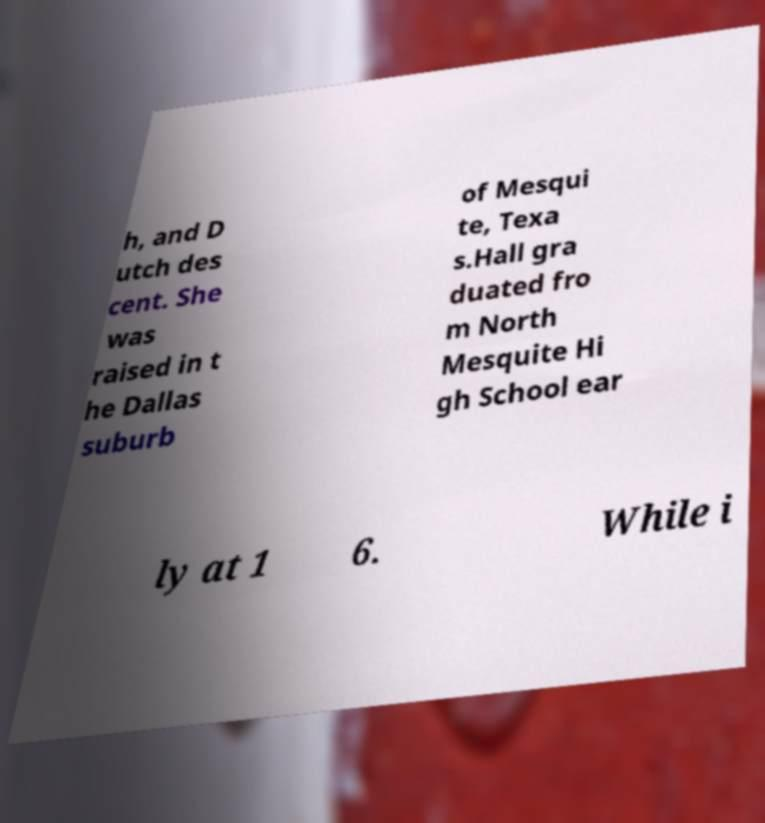What messages or text are displayed in this image? I need them in a readable, typed format. h, and D utch des cent. She was raised in t he Dallas suburb of Mesqui te, Texa s.Hall gra duated fro m North Mesquite Hi gh School ear ly at 1 6. While i 